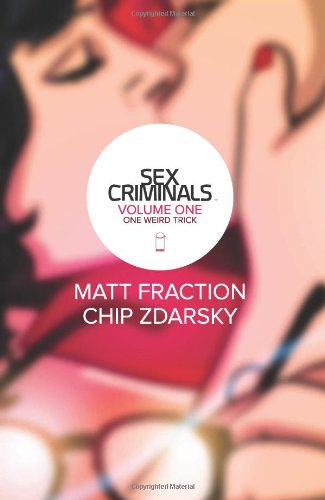What is the title of this book? The title of the book you're referring to is 'Sex Criminals, Vol. 1: One Weird Trick.' This is the first volume in an intriguing series of graphic novels. 